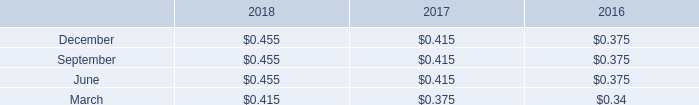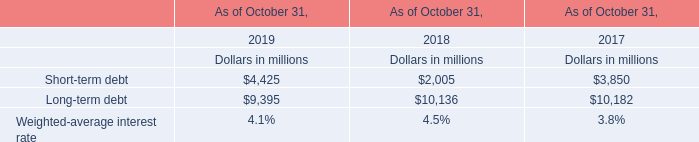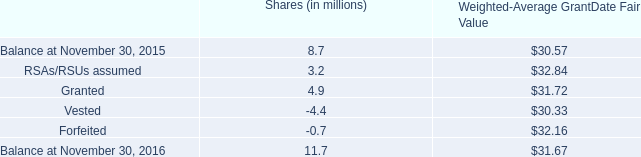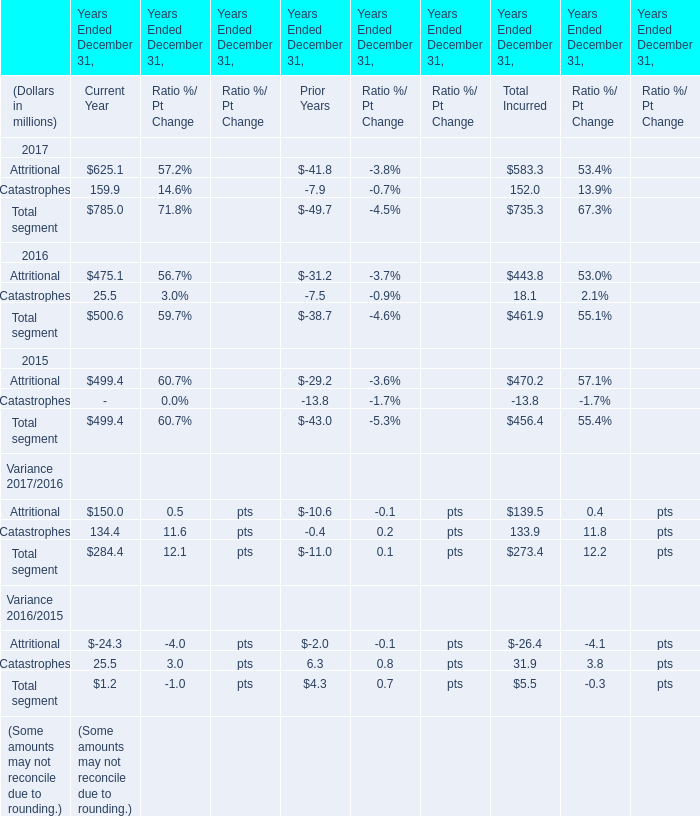during 2018 , 2017 and 2016 , what did the company pay ( millions ) in cash dividends? 
Computations: ((319 + 289) + 261)
Answer: 869.0. 